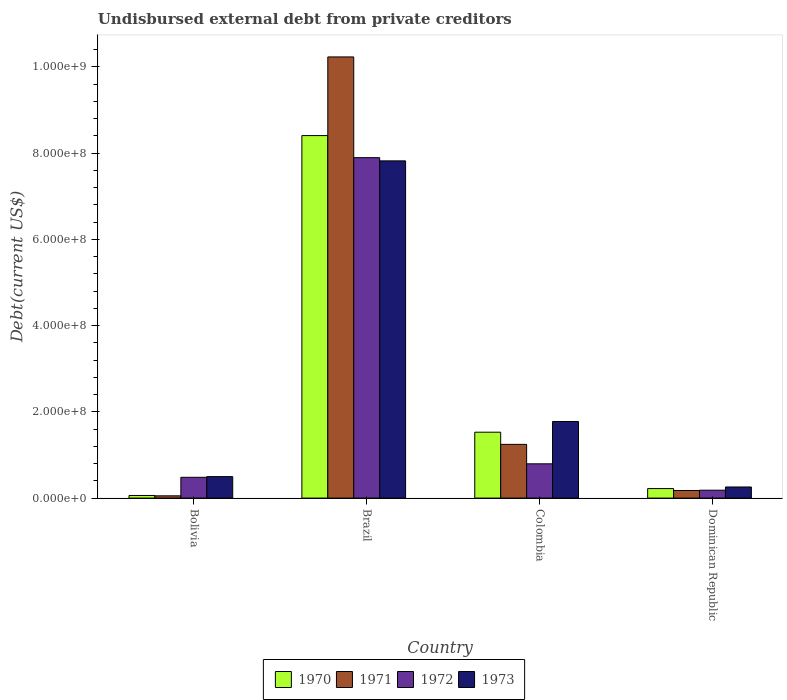How many different coloured bars are there?
Offer a terse response. 4. Are the number of bars on each tick of the X-axis equal?
Provide a short and direct response. Yes. What is the label of the 4th group of bars from the left?
Keep it short and to the point. Dominican Republic. In how many cases, is the number of bars for a given country not equal to the number of legend labels?
Provide a succinct answer. 0. What is the total debt in 1970 in Bolivia?
Offer a very short reply. 6.05e+06. Across all countries, what is the maximum total debt in 1973?
Keep it short and to the point. 7.82e+08. Across all countries, what is the minimum total debt in 1972?
Keep it short and to the point. 1.83e+07. In which country was the total debt in 1972 minimum?
Make the answer very short. Dominican Republic. What is the total total debt in 1970 in the graph?
Keep it short and to the point. 1.02e+09. What is the difference between the total debt in 1972 in Brazil and that in Dominican Republic?
Make the answer very short. 7.71e+08. What is the difference between the total debt in 1973 in Brazil and the total debt in 1972 in Dominican Republic?
Your response must be concise. 7.64e+08. What is the average total debt in 1971 per country?
Your answer should be very brief. 2.93e+08. What is the difference between the total debt of/in 1972 and total debt of/in 1971 in Brazil?
Offer a terse response. -2.34e+08. In how many countries, is the total debt in 1970 greater than 440000000 US$?
Keep it short and to the point. 1. What is the ratio of the total debt in 1973 in Bolivia to that in Brazil?
Your answer should be very brief. 0.06. Is the total debt in 1973 in Bolivia less than that in Dominican Republic?
Your answer should be compact. No. What is the difference between the highest and the second highest total debt in 1973?
Make the answer very short. 6.04e+08. What is the difference between the highest and the lowest total debt in 1971?
Your answer should be compact. 1.02e+09. Is it the case that in every country, the sum of the total debt in 1973 and total debt in 1971 is greater than the sum of total debt in 1972 and total debt in 1970?
Offer a terse response. No. What does the 3rd bar from the right in Dominican Republic represents?
Your answer should be very brief. 1971. Is it the case that in every country, the sum of the total debt in 1971 and total debt in 1970 is greater than the total debt in 1972?
Make the answer very short. No. How many countries are there in the graph?
Keep it short and to the point. 4. What is the difference between two consecutive major ticks on the Y-axis?
Ensure brevity in your answer.  2.00e+08. Where does the legend appear in the graph?
Ensure brevity in your answer.  Bottom center. How many legend labels are there?
Provide a succinct answer. 4. What is the title of the graph?
Offer a very short reply. Undisbursed external debt from private creditors. What is the label or title of the Y-axis?
Provide a succinct answer. Debt(current US$). What is the Debt(current US$) of 1970 in Bolivia?
Offer a very short reply. 6.05e+06. What is the Debt(current US$) in 1971 in Bolivia?
Give a very brief answer. 5.25e+06. What is the Debt(current US$) in 1972 in Bolivia?
Give a very brief answer. 4.82e+07. What is the Debt(current US$) of 1973 in Bolivia?
Offer a terse response. 4.98e+07. What is the Debt(current US$) of 1970 in Brazil?
Offer a terse response. 8.41e+08. What is the Debt(current US$) in 1971 in Brazil?
Offer a very short reply. 1.02e+09. What is the Debt(current US$) in 1972 in Brazil?
Keep it short and to the point. 7.89e+08. What is the Debt(current US$) of 1973 in Brazil?
Offer a terse response. 7.82e+08. What is the Debt(current US$) in 1970 in Colombia?
Keep it short and to the point. 1.53e+08. What is the Debt(current US$) of 1971 in Colombia?
Ensure brevity in your answer.  1.25e+08. What is the Debt(current US$) in 1972 in Colombia?
Offer a very short reply. 7.95e+07. What is the Debt(current US$) of 1973 in Colombia?
Keep it short and to the point. 1.78e+08. What is the Debt(current US$) of 1970 in Dominican Republic?
Ensure brevity in your answer.  2.21e+07. What is the Debt(current US$) of 1971 in Dominican Republic?
Provide a succinct answer. 1.76e+07. What is the Debt(current US$) of 1972 in Dominican Republic?
Provide a short and direct response. 1.83e+07. What is the Debt(current US$) in 1973 in Dominican Republic?
Offer a terse response. 2.58e+07. Across all countries, what is the maximum Debt(current US$) in 1970?
Give a very brief answer. 8.41e+08. Across all countries, what is the maximum Debt(current US$) in 1971?
Give a very brief answer. 1.02e+09. Across all countries, what is the maximum Debt(current US$) in 1972?
Give a very brief answer. 7.89e+08. Across all countries, what is the maximum Debt(current US$) of 1973?
Your answer should be very brief. 7.82e+08. Across all countries, what is the minimum Debt(current US$) of 1970?
Provide a short and direct response. 6.05e+06. Across all countries, what is the minimum Debt(current US$) in 1971?
Offer a very short reply. 5.25e+06. Across all countries, what is the minimum Debt(current US$) in 1972?
Your response must be concise. 1.83e+07. Across all countries, what is the minimum Debt(current US$) in 1973?
Offer a very short reply. 2.58e+07. What is the total Debt(current US$) of 1970 in the graph?
Your answer should be very brief. 1.02e+09. What is the total Debt(current US$) in 1971 in the graph?
Your response must be concise. 1.17e+09. What is the total Debt(current US$) in 1972 in the graph?
Your answer should be very brief. 9.35e+08. What is the total Debt(current US$) of 1973 in the graph?
Your response must be concise. 1.04e+09. What is the difference between the Debt(current US$) in 1970 in Bolivia and that in Brazil?
Offer a very short reply. -8.35e+08. What is the difference between the Debt(current US$) in 1971 in Bolivia and that in Brazil?
Keep it short and to the point. -1.02e+09. What is the difference between the Debt(current US$) of 1972 in Bolivia and that in Brazil?
Keep it short and to the point. -7.41e+08. What is the difference between the Debt(current US$) in 1973 in Bolivia and that in Brazil?
Provide a succinct answer. -7.32e+08. What is the difference between the Debt(current US$) of 1970 in Bolivia and that in Colombia?
Your answer should be compact. -1.47e+08. What is the difference between the Debt(current US$) in 1971 in Bolivia and that in Colombia?
Your answer should be compact. -1.19e+08. What is the difference between the Debt(current US$) of 1972 in Bolivia and that in Colombia?
Provide a succinct answer. -3.13e+07. What is the difference between the Debt(current US$) in 1973 in Bolivia and that in Colombia?
Ensure brevity in your answer.  -1.28e+08. What is the difference between the Debt(current US$) in 1970 in Bolivia and that in Dominican Republic?
Keep it short and to the point. -1.60e+07. What is the difference between the Debt(current US$) of 1971 in Bolivia and that in Dominican Republic?
Make the answer very short. -1.24e+07. What is the difference between the Debt(current US$) of 1972 in Bolivia and that in Dominican Republic?
Provide a succinct answer. 2.99e+07. What is the difference between the Debt(current US$) of 1973 in Bolivia and that in Dominican Republic?
Your response must be concise. 2.40e+07. What is the difference between the Debt(current US$) of 1970 in Brazil and that in Colombia?
Your answer should be very brief. 6.88e+08. What is the difference between the Debt(current US$) in 1971 in Brazil and that in Colombia?
Your answer should be very brief. 8.98e+08. What is the difference between the Debt(current US$) in 1972 in Brazil and that in Colombia?
Keep it short and to the point. 7.10e+08. What is the difference between the Debt(current US$) in 1973 in Brazil and that in Colombia?
Your response must be concise. 6.04e+08. What is the difference between the Debt(current US$) in 1970 in Brazil and that in Dominican Republic?
Provide a succinct answer. 8.19e+08. What is the difference between the Debt(current US$) in 1971 in Brazil and that in Dominican Republic?
Offer a very short reply. 1.01e+09. What is the difference between the Debt(current US$) of 1972 in Brazil and that in Dominican Republic?
Offer a terse response. 7.71e+08. What is the difference between the Debt(current US$) of 1973 in Brazil and that in Dominican Republic?
Your answer should be very brief. 7.56e+08. What is the difference between the Debt(current US$) of 1970 in Colombia and that in Dominican Republic?
Ensure brevity in your answer.  1.31e+08. What is the difference between the Debt(current US$) in 1971 in Colombia and that in Dominican Republic?
Provide a short and direct response. 1.07e+08. What is the difference between the Debt(current US$) of 1972 in Colombia and that in Dominican Republic?
Keep it short and to the point. 6.12e+07. What is the difference between the Debt(current US$) of 1973 in Colombia and that in Dominican Republic?
Provide a succinct answer. 1.52e+08. What is the difference between the Debt(current US$) of 1970 in Bolivia and the Debt(current US$) of 1971 in Brazil?
Provide a short and direct response. -1.02e+09. What is the difference between the Debt(current US$) of 1970 in Bolivia and the Debt(current US$) of 1972 in Brazil?
Provide a succinct answer. -7.83e+08. What is the difference between the Debt(current US$) in 1970 in Bolivia and the Debt(current US$) in 1973 in Brazil?
Your response must be concise. -7.76e+08. What is the difference between the Debt(current US$) in 1971 in Bolivia and the Debt(current US$) in 1972 in Brazil?
Ensure brevity in your answer.  -7.84e+08. What is the difference between the Debt(current US$) of 1971 in Bolivia and the Debt(current US$) of 1973 in Brazil?
Ensure brevity in your answer.  -7.77e+08. What is the difference between the Debt(current US$) of 1972 in Bolivia and the Debt(current US$) of 1973 in Brazil?
Give a very brief answer. -7.34e+08. What is the difference between the Debt(current US$) in 1970 in Bolivia and the Debt(current US$) in 1971 in Colombia?
Provide a succinct answer. -1.19e+08. What is the difference between the Debt(current US$) in 1970 in Bolivia and the Debt(current US$) in 1972 in Colombia?
Keep it short and to the point. -7.34e+07. What is the difference between the Debt(current US$) in 1970 in Bolivia and the Debt(current US$) in 1973 in Colombia?
Provide a succinct answer. -1.72e+08. What is the difference between the Debt(current US$) of 1971 in Bolivia and the Debt(current US$) of 1972 in Colombia?
Your answer should be very brief. -7.42e+07. What is the difference between the Debt(current US$) of 1971 in Bolivia and the Debt(current US$) of 1973 in Colombia?
Provide a short and direct response. -1.72e+08. What is the difference between the Debt(current US$) in 1972 in Bolivia and the Debt(current US$) in 1973 in Colombia?
Your response must be concise. -1.29e+08. What is the difference between the Debt(current US$) of 1970 in Bolivia and the Debt(current US$) of 1971 in Dominican Republic?
Provide a succinct answer. -1.16e+07. What is the difference between the Debt(current US$) of 1970 in Bolivia and the Debt(current US$) of 1972 in Dominican Republic?
Keep it short and to the point. -1.23e+07. What is the difference between the Debt(current US$) of 1970 in Bolivia and the Debt(current US$) of 1973 in Dominican Republic?
Ensure brevity in your answer.  -1.97e+07. What is the difference between the Debt(current US$) of 1971 in Bolivia and the Debt(current US$) of 1972 in Dominican Republic?
Offer a terse response. -1.31e+07. What is the difference between the Debt(current US$) of 1971 in Bolivia and the Debt(current US$) of 1973 in Dominican Republic?
Provide a succinct answer. -2.05e+07. What is the difference between the Debt(current US$) in 1972 in Bolivia and the Debt(current US$) in 1973 in Dominican Republic?
Make the answer very short. 2.24e+07. What is the difference between the Debt(current US$) of 1970 in Brazil and the Debt(current US$) of 1971 in Colombia?
Your response must be concise. 7.16e+08. What is the difference between the Debt(current US$) of 1970 in Brazil and the Debt(current US$) of 1972 in Colombia?
Your answer should be very brief. 7.61e+08. What is the difference between the Debt(current US$) of 1970 in Brazil and the Debt(current US$) of 1973 in Colombia?
Your response must be concise. 6.63e+08. What is the difference between the Debt(current US$) of 1971 in Brazil and the Debt(current US$) of 1972 in Colombia?
Provide a succinct answer. 9.44e+08. What is the difference between the Debt(current US$) in 1971 in Brazil and the Debt(current US$) in 1973 in Colombia?
Your answer should be very brief. 8.45e+08. What is the difference between the Debt(current US$) in 1972 in Brazil and the Debt(current US$) in 1973 in Colombia?
Provide a succinct answer. 6.12e+08. What is the difference between the Debt(current US$) in 1970 in Brazil and the Debt(current US$) in 1971 in Dominican Republic?
Give a very brief answer. 8.23e+08. What is the difference between the Debt(current US$) in 1970 in Brazil and the Debt(current US$) in 1972 in Dominican Republic?
Your answer should be compact. 8.22e+08. What is the difference between the Debt(current US$) of 1970 in Brazil and the Debt(current US$) of 1973 in Dominican Republic?
Your response must be concise. 8.15e+08. What is the difference between the Debt(current US$) of 1971 in Brazil and the Debt(current US$) of 1972 in Dominican Republic?
Give a very brief answer. 1.00e+09. What is the difference between the Debt(current US$) of 1971 in Brazil and the Debt(current US$) of 1973 in Dominican Republic?
Provide a succinct answer. 9.97e+08. What is the difference between the Debt(current US$) of 1972 in Brazil and the Debt(current US$) of 1973 in Dominican Republic?
Offer a terse response. 7.64e+08. What is the difference between the Debt(current US$) in 1970 in Colombia and the Debt(current US$) in 1971 in Dominican Republic?
Your answer should be very brief. 1.35e+08. What is the difference between the Debt(current US$) of 1970 in Colombia and the Debt(current US$) of 1972 in Dominican Republic?
Your answer should be very brief. 1.34e+08. What is the difference between the Debt(current US$) of 1970 in Colombia and the Debt(current US$) of 1973 in Dominican Republic?
Offer a very short reply. 1.27e+08. What is the difference between the Debt(current US$) in 1971 in Colombia and the Debt(current US$) in 1972 in Dominican Republic?
Give a very brief answer. 1.06e+08. What is the difference between the Debt(current US$) of 1971 in Colombia and the Debt(current US$) of 1973 in Dominican Republic?
Offer a terse response. 9.88e+07. What is the difference between the Debt(current US$) in 1972 in Colombia and the Debt(current US$) in 1973 in Dominican Republic?
Ensure brevity in your answer.  5.37e+07. What is the average Debt(current US$) of 1970 per country?
Provide a succinct answer. 2.55e+08. What is the average Debt(current US$) in 1971 per country?
Your answer should be compact. 2.93e+08. What is the average Debt(current US$) of 1972 per country?
Give a very brief answer. 2.34e+08. What is the average Debt(current US$) in 1973 per country?
Offer a terse response. 2.59e+08. What is the difference between the Debt(current US$) of 1970 and Debt(current US$) of 1971 in Bolivia?
Ensure brevity in your answer.  8.02e+05. What is the difference between the Debt(current US$) in 1970 and Debt(current US$) in 1972 in Bolivia?
Provide a succinct answer. -4.22e+07. What is the difference between the Debt(current US$) of 1970 and Debt(current US$) of 1973 in Bolivia?
Offer a terse response. -4.37e+07. What is the difference between the Debt(current US$) in 1971 and Debt(current US$) in 1972 in Bolivia?
Offer a terse response. -4.30e+07. What is the difference between the Debt(current US$) of 1971 and Debt(current US$) of 1973 in Bolivia?
Offer a terse response. -4.45e+07. What is the difference between the Debt(current US$) of 1972 and Debt(current US$) of 1973 in Bolivia?
Keep it short and to the point. -1.58e+06. What is the difference between the Debt(current US$) in 1970 and Debt(current US$) in 1971 in Brazil?
Offer a terse response. -1.82e+08. What is the difference between the Debt(current US$) of 1970 and Debt(current US$) of 1972 in Brazil?
Provide a succinct answer. 5.12e+07. What is the difference between the Debt(current US$) of 1970 and Debt(current US$) of 1973 in Brazil?
Provide a succinct answer. 5.86e+07. What is the difference between the Debt(current US$) of 1971 and Debt(current US$) of 1972 in Brazil?
Your answer should be very brief. 2.34e+08. What is the difference between the Debt(current US$) of 1971 and Debt(current US$) of 1973 in Brazil?
Give a very brief answer. 2.41e+08. What is the difference between the Debt(current US$) of 1972 and Debt(current US$) of 1973 in Brazil?
Keep it short and to the point. 7.41e+06. What is the difference between the Debt(current US$) in 1970 and Debt(current US$) in 1971 in Colombia?
Offer a very short reply. 2.82e+07. What is the difference between the Debt(current US$) of 1970 and Debt(current US$) of 1972 in Colombia?
Offer a terse response. 7.33e+07. What is the difference between the Debt(current US$) in 1970 and Debt(current US$) in 1973 in Colombia?
Your response must be concise. -2.48e+07. What is the difference between the Debt(current US$) of 1971 and Debt(current US$) of 1972 in Colombia?
Your answer should be compact. 4.51e+07. What is the difference between the Debt(current US$) in 1971 and Debt(current US$) in 1973 in Colombia?
Your response must be concise. -5.30e+07. What is the difference between the Debt(current US$) of 1972 and Debt(current US$) of 1973 in Colombia?
Your answer should be compact. -9.81e+07. What is the difference between the Debt(current US$) in 1970 and Debt(current US$) in 1971 in Dominican Republic?
Provide a succinct answer. 4.46e+06. What is the difference between the Debt(current US$) of 1970 and Debt(current US$) of 1972 in Dominican Republic?
Your response must be concise. 3.78e+06. What is the difference between the Debt(current US$) of 1970 and Debt(current US$) of 1973 in Dominican Republic?
Provide a succinct answer. -3.68e+06. What is the difference between the Debt(current US$) of 1971 and Debt(current US$) of 1972 in Dominican Republic?
Provide a succinct answer. -6.84e+05. What is the difference between the Debt(current US$) of 1971 and Debt(current US$) of 1973 in Dominican Republic?
Keep it short and to the point. -8.14e+06. What is the difference between the Debt(current US$) in 1972 and Debt(current US$) in 1973 in Dominican Republic?
Your response must be concise. -7.46e+06. What is the ratio of the Debt(current US$) in 1970 in Bolivia to that in Brazil?
Ensure brevity in your answer.  0.01. What is the ratio of the Debt(current US$) of 1971 in Bolivia to that in Brazil?
Your response must be concise. 0.01. What is the ratio of the Debt(current US$) of 1972 in Bolivia to that in Brazil?
Your response must be concise. 0.06. What is the ratio of the Debt(current US$) in 1973 in Bolivia to that in Brazil?
Provide a succinct answer. 0.06. What is the ratio of the Debt(current US$) in 1970 in Bolivia to that in Colombia?
Provide a short and direct response. 0.04. What is the ratio of the Debt(current US$) of 1971 in Bolivia to that in Colombia?
Provide a short and direct response. 0.04. What is the ratio of the Debt(current US$) in 1972 in Bolivia to that in Colombia?
Make the answer very short. 0.61. What is the ratio of the Debt(current US$) in 1973 in Bolivia to that in Colombia?
Make the answer very short. 0.28. What is the ratio of the Debt(current US$) of 1970 in Bolivia to that in Dominican Republic?
Give a very brief answer. 0.27. What is the ratio of the Debt(current US$) of 1971 in Bolivia to that in Dominican Republic?
Offer a terse response. 0.3. What is the ratio of the Debt(current US$) in 1972 in Bolivia to that in Dominican Republic?
Provide a succinct answer. 2.63. What is the ratio of the Debt(current US$) of 1973 in Bolivia to that in Dominican Republic?
Provide a succinct answer. 1.93. What is the ratio of the Debt(current US$) of 1970 in Brazil to that in Colombia?
Your answer should be compact. 5.5. What is the ratio of the Debt(current US$) of 1971 in Brazil to that in Colombia?
Your answer should be compact. 8.21. What is the ratio of the Debt(current US$) of 1972 in Brazil to that in Colombia?
Offer a terse response. 9.93. What is the ratio of the Debt(current US$) in 1973 in Brazil to that in Colombia?
Ensure brevity in your answer.  4.4. What is the ratio of the Debt(current US$) of 1970 in Brazil to that in Dominican Republic?
Give a very brief answer. 38.04. What is the ratio of the Debt(current US$) in 1971 in Brazil to that in Dominican Republic?
Offer a terse response. 58.02. What is the ratio of the Debt(current US$) of 1972 in Brazil to that in Dominican Republic?
Give a very brief answer. 43.1. What is the ratio of the Debt(current US$) in 1973 in Brazil to that in Dominican Republic?
Provide a short and direct response. 30.34. What is the ratio of the Debt(current US$) of 1970 in Colombia to that in Dominican Republic?
Your answer should be very brief. 6.92. What is the ratio of the Debt(current US$) in 1971 in Colombia to that in Dominican Republic?
Offer a very short reply. 7.07. What is the ratio of the Debt(current US$) of 1972 in Colombia to that in Dominican Republic?
Give a very brief answer. 4.34. What is the ratio of the Debt(current US$) in 1973 in Colombia to that in Dominican Republic?
Your answer should be compact. 6.89. What is the difference between the highest and the second highest Debt(current US$) in 1970?
Provide a short and direct response. 6.88e+08. What is the difference between the highest and the second highest Debt(current US$) in 1971?
Make the answer very short. 8.98e+08. What is the difference between the highest and the second highest Debt(current US$) in 1972?
Keep it short and to the point. 7.10e+08. What is the difference between the highest and the second highest Debt(current US$) of 1973?
Your answer should be very brief. 6.04e+08. What is the difference between the highest and the lowest Debt(current US$) in 1970?
Your response must be concise. 8.35e+08. What is the difference between the highest and the lowest Debt(current US$) in 1971?
Ensure brevity in your answer.  1.02e+09. What is the difference between the highest and the lowest Debt(current US$) of 1972?
Your answer should be very brief. 7.71e+08. What is the difference between the highest and the lowest Debt(current US$) of 1973?
Provide a short and direct response. 7.56e+08. 